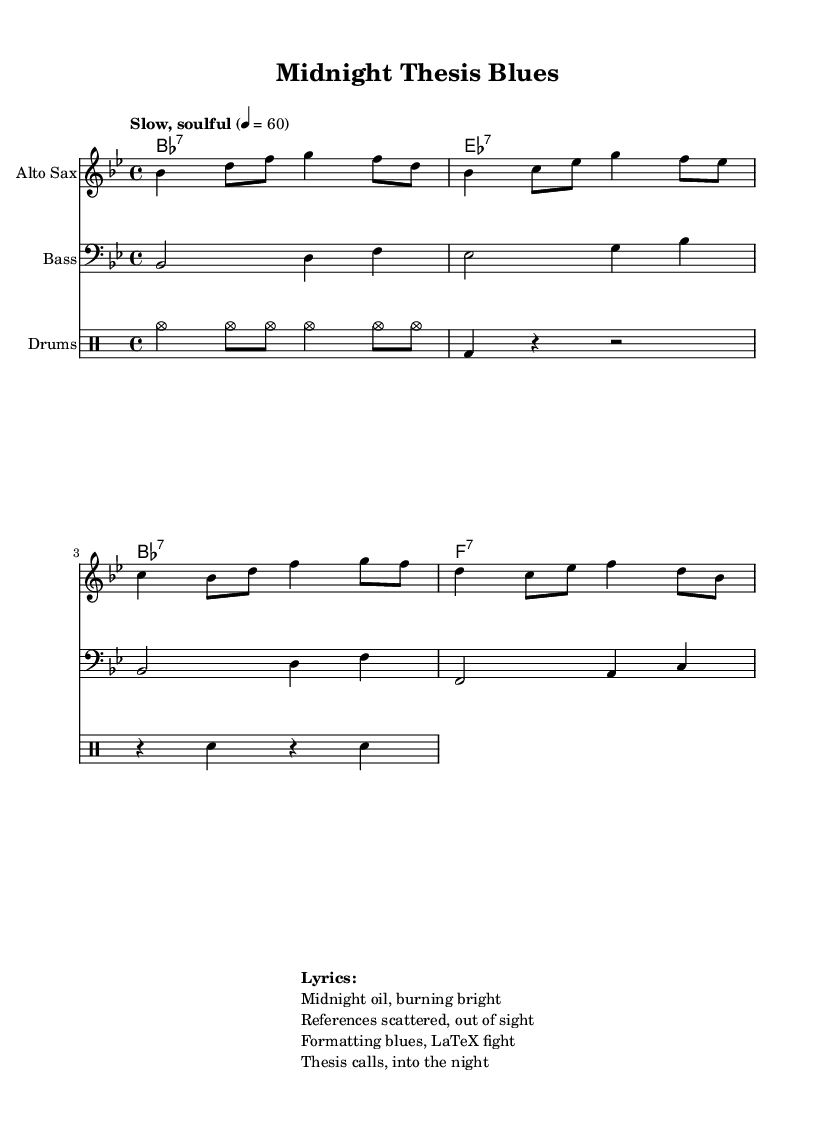What is the key signature of this music? The key signature is indicated at the beginning of the music sheet. It shows two flats (B flat and E flat), which corresponds to the key of B flat major.
Answer: B flat major What is the time signature of this music? The time signature is shown at the beginning of the sheet music with the numbers 4 over 4. This means there are four beats in each measure, and the quarter note gets one beat.
Answer: 4/4 What tempo marking is used in the music? The tempo marking is found at the beginning, stating "Slow, soulful" with a metronome marking of 60 beats per minute, indicating a relaxed and expressive pace.
Answer: Slow, soulful How many measures are there in the melody? By counting the distinct sections separated by vertical lines in the melody, we see there are eight measures in total in the melody line.
Answer: 8 What instrument plays the melody? The instrument designation is shown on the staff, indicating that the melody is played on the "Alto Sax."
Answer: Alto Sax What type of chord progression is used in the chord names? The chord names located above the staff show a progression typical for jazz, featuring seventh chords: B flat major seven, E flat major seven, B flat major seven, and F major seven.
Answer: Seventh chords What are the lyrics of the song? The lyrics are indicated below the music and consist of four lines reflecting the theme of working late on a thesis, highlighting the struggles faced during late-night research sessions.
Answer: Midnight oil, burning bright 